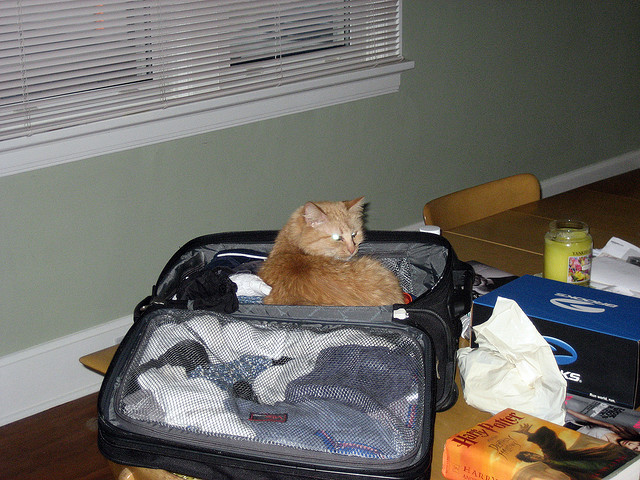Please transcribe the text information in this image. Harry Potter KS. 